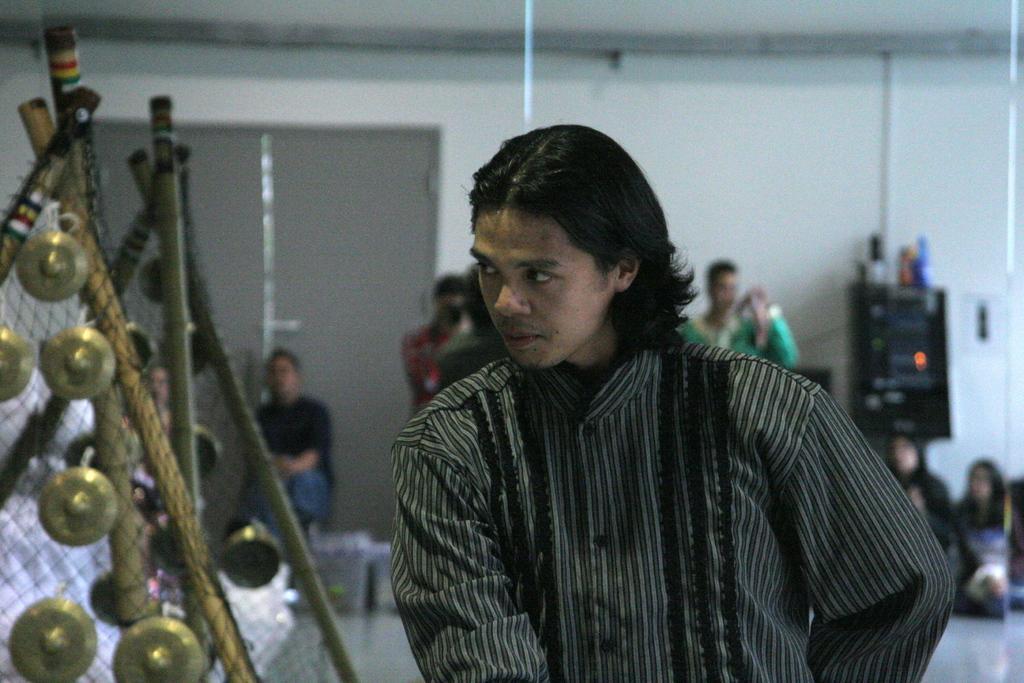Describe this image in one or two sentences. In this image, we can see a man. On the left side of the image, we can see sticks, balls and net. Background there is a blur view. Here we can see people, wall, door, floor and few objects. 